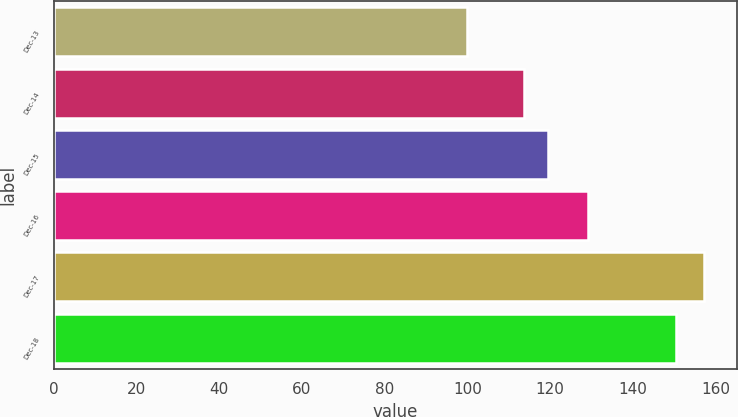Convert chart to OTSL. <chart><loc_0><loc_0><loc_500><loc_500><bar_chart><fcel>Dec-13<fcel>Dec-14<fcel>Dec-15<fcel>Dec-16<fcel>Dec-17<fcel>Dec-18<nl><fcel>100<fcel>113.69<fcel>119.41<fcel>129.05<fcel>157.22<fcel>150.33<nl></chart> 